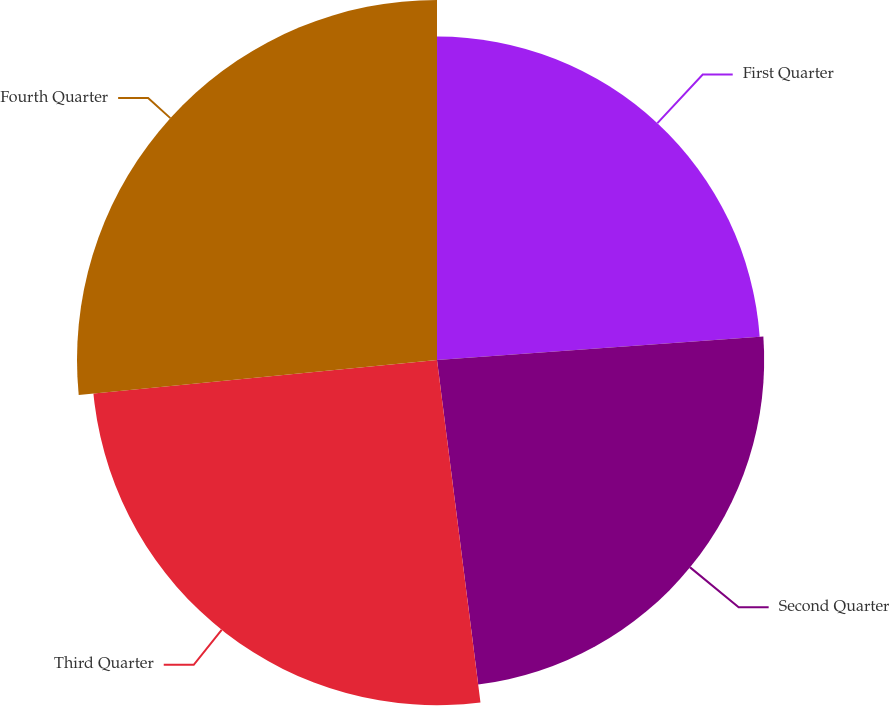Convert chart to OTSL. <chart><loc_0><loc_0><loc_500><loc_500><pie_chart><fcel>First Quarter<fcel>Second Quarter<fcel>Third Quarter<fcel>Fourth Quarter<nl><fcel>23.86%<fcel>24.13%<fcel>25.46%<fcel>26.55%<nl></chart> 